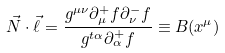<formula> <loc_0><loc_0><loc_500><loc_500>\vec { N } \cdot \vec { \ell } = \frac { g ^ { \mu \nu } \partial _ { \mu } ^ { + } f \partial _ { \nu } ^ { - } f } { g ^ { t \alpha } \partial _ { \alpha } ^ { + } f } \equiv B ( x ^ { \mu } )</formula> 